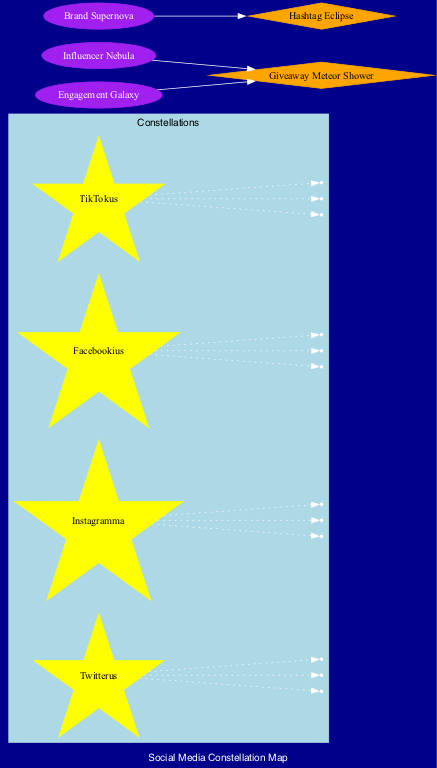What is the shape of the constellation Twitterus? The shape of Twitterus, as indicated in the diagram, is a "Bird silhouette."
Answer: Bird silhouette How many key stars are associated with the constellation Instagramma? Instagramma has three key stars: Filteria, Storius, and Reelus, as listed under its details in the diagram. Therefore, the total count is 3.
Answer: 3 Which celestial object is described as a "Cluster of rising stars"? The celestial object described in the diagram as a "Cluster of rising stars" is the Influencer Nebula.
Answer: Influencer Nebula What is the relationship between the Engagement Galaxy and the Giveaway Meteor Shower? The diagram shows a directed edge from Engagement Galaxy to Giveaway Meteor Shower, indicating that the Engagement Galaxy is connected to the Giveaway Meteor Shower.
Answer: Connected How many constellations are displayed in the diagram? The diagram lists four constellations: Twitterus, Instagramma, Facebookius, and TikTokus. Therefore, the total count of constellations is 4.
Answer: 4 Which celestial event is associated with the Brand Supernova? The diagram presents a directed edge from Brand Supernova to Hashtag Eclipse, indicating the relationship. Therefore, the answer is Hashtag Eclipse.
Answer: Hashtag Eclipse What shape does the constellation Facebookius resemble? The shape of Facebookius, as identified in the diagram, resembles a "Thumbs up."
Answer: Thumbs up How many edges stem from the constellation TikTokus? The constellation TikTokus has three key stars connected to it: Duettus, Trendius, and Viralia. Thus, there are three edges stemming from TikTokus.
Answer: 3 